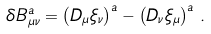<formula> <loc_0><loc_0><loc_500><loc_500>\delta B _ { \mu \nu } ^ { a } = \left ( D _ { \mu } \xi _ { \nu } \right ) ^ { a } - \left ( D _ { \nu } \xi _ { \mu } \right ) ^ { a } \, .</formula> 